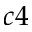Convert formula to latex. <formula><loc_0><loc_0><loc_500><loc_500>c 4</formula> 